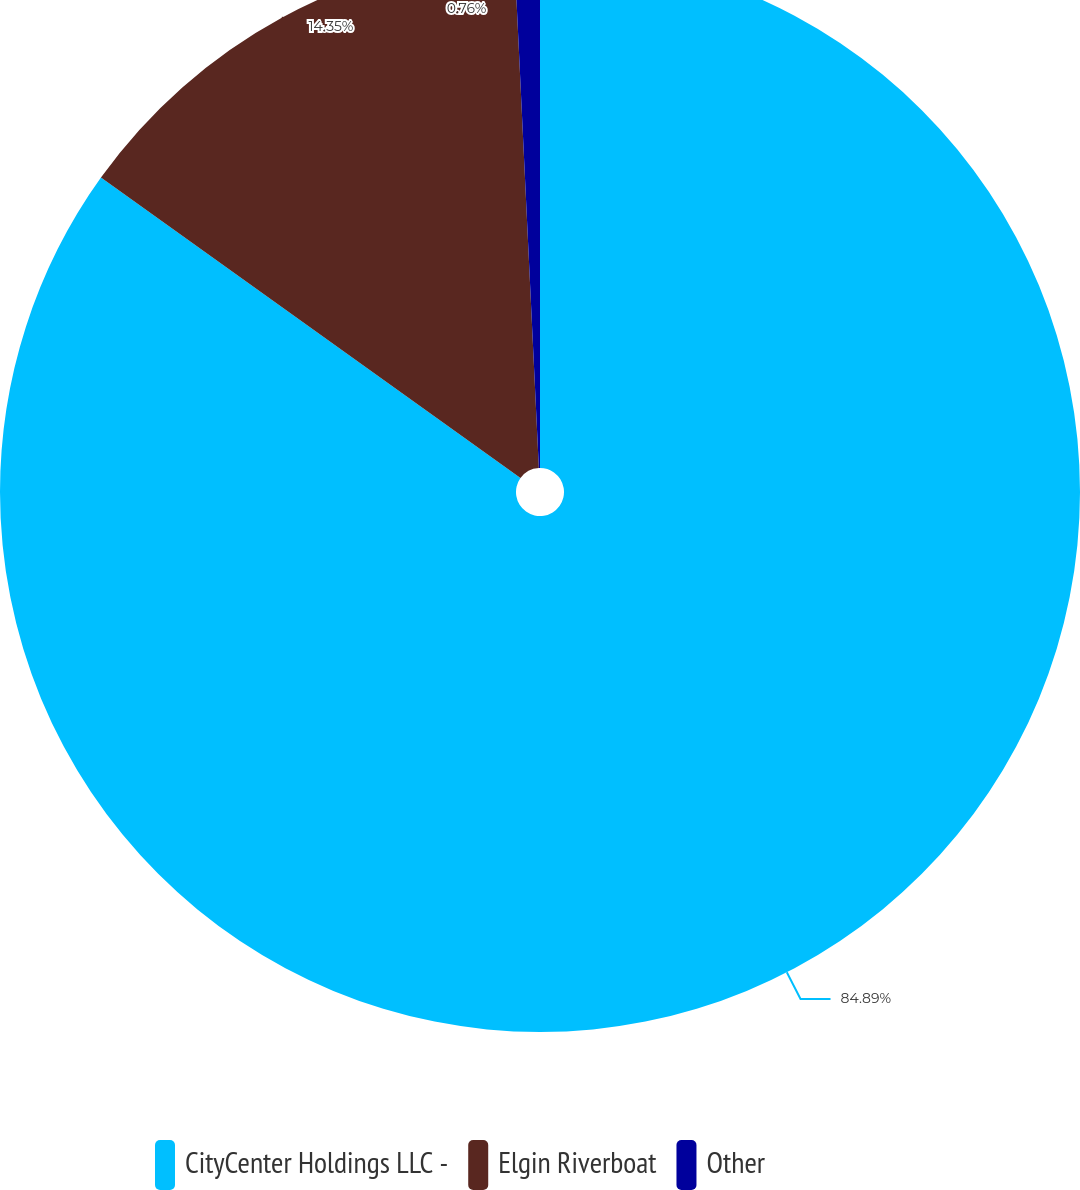Convert chart. <chart><loc_0><loc_0><loc_500><loc_500><pie_chart><fcel>CityCenter Holdings LLC -<fcel>Elgin Riverboat<fcel>Other<nl><fcel>84.89%<fcel>14.35%<fcel>0.76%<nl></chart> 